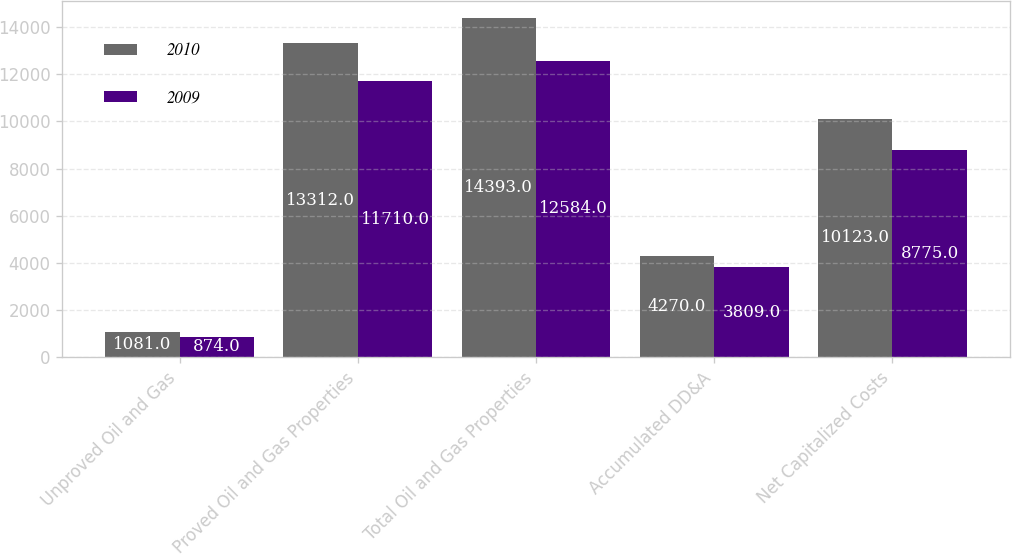Convert chart to OTSL. <chart><loc_0><loc_0><loc_500><loc_500><stacked_bar_chart><ecel><fcel>Unproved Oil and Gas<fcel>Proved Oil and Gas Properties<fcel>Total Oil and Gas Properties<fcel>Accumulated DD&A<fcel>Net Capitalized Costs<nl><fcel>2010<fcel>1081<fcel>13312<fcel>14393<fcel>4270<fcel>10123<nl><fcel>2009<fcel>874<fcel>11710<fcel>12584<fcel>3809<fcel>8775<nl></chart> 